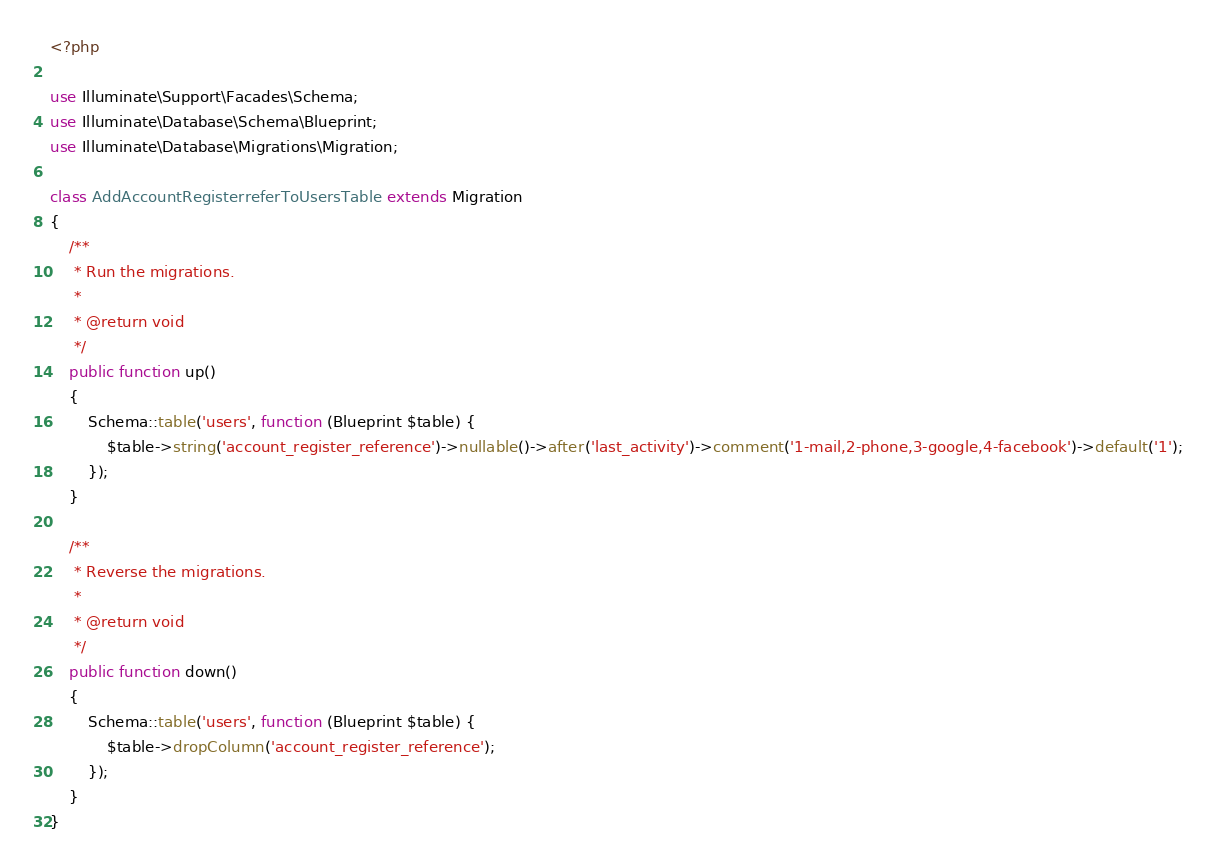<code> <loc_0><loc_0><loc_500><loc_500><_PHP_><?php

use Illuminate\Support\Facades\Schema;
use Illuminate\Database\Schema\Blueprint;
use Illuminate\Database\Migrations\Migration;

class AddAccountRegisterreferToUsersTable extends Migration
{
    /**
     * Run the migrations.
     *
     * @return void
     */
    public function up()
    {
        Schema::table('users', function (Blueprint $table) {
            $table->string('account_register_reference')->nullable()->after('last_activity')->comment('1-mail,2-phone,3-google,4-facebook')->default('1');
        });
    }

    /**
     * Reverse the migrations.
     *
     * @return void
     */
    public function down()
    {
        Schema::table('users', function (Blueprint $table) {
            $table->dropColumn('account_register_reference');
        });
    }
}
</code> 